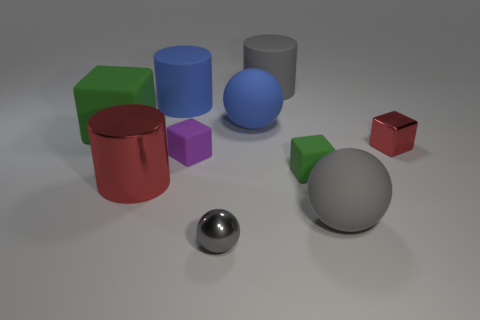What shape is the big gray thing in front of the tiny matte cube that is on the left side of the large blue matte ball that is to the right of the big green matte block?
Keep it short and to the point. Sphere. What number of big blue matte objects have the same shape as the tiny green object?
Ensure brevity in your answer.  0. What is the material of the large cylinder that is the same color as the small shiny sphere?
Give a very brief answer. Rubber. Are the small gray ball and the small green block made of the same material?
Your response must be concise. No. How many things are on the right side of the gray ball left of the big rubber object in front of the big block?
Your response must be concise. 5. Are there any small purple objects that have the same material as the red cylinder?
Offer a very short reply. No. There is a metal object that is the same color as the shiny cube; what is its size?
Your response must be concise. Large. Is the number of large blue matte things less than the number of small spheres?
Offer a very short reply. No. Is the color of the tiny metallic object on the left side of the tiny green matte object the same as the small metal block?
Keep it short and to the point. No. There is a large cylinder right of the gray sphere that is left of the cylinder that is to the right of the big blue matte ball; what is its material?
Your answer should be very brief. Rubber. 